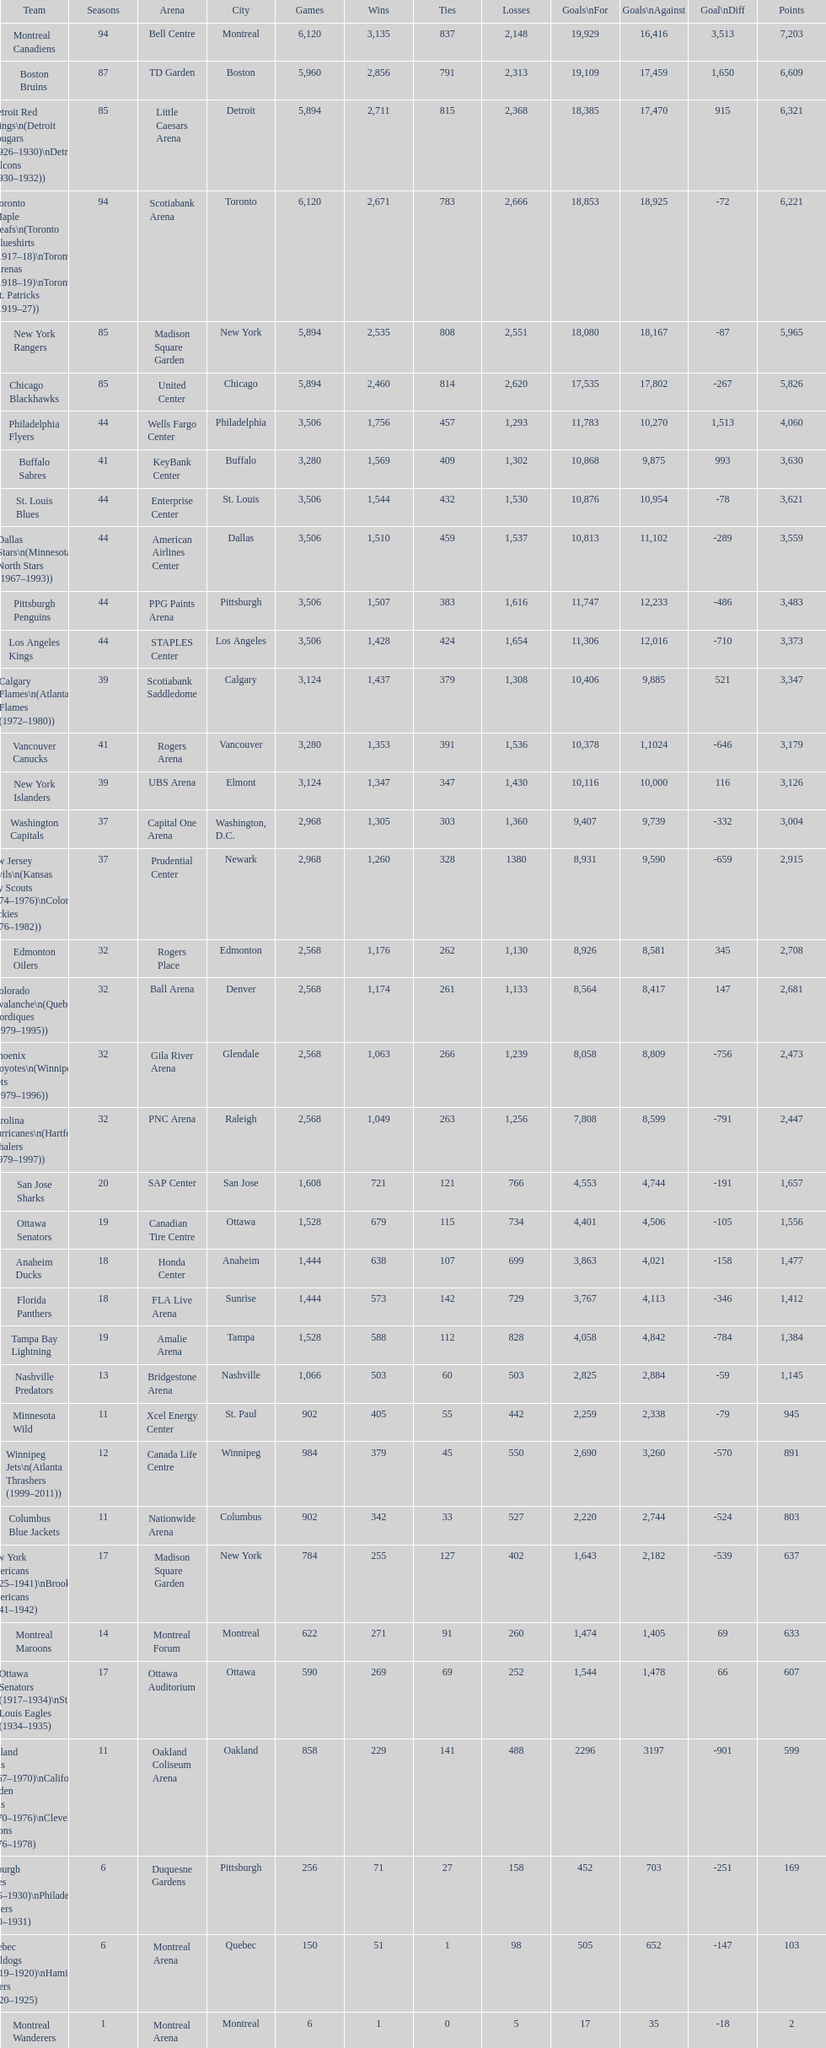Which team was last in terms of points up until this point? Montreal Wanderers. 